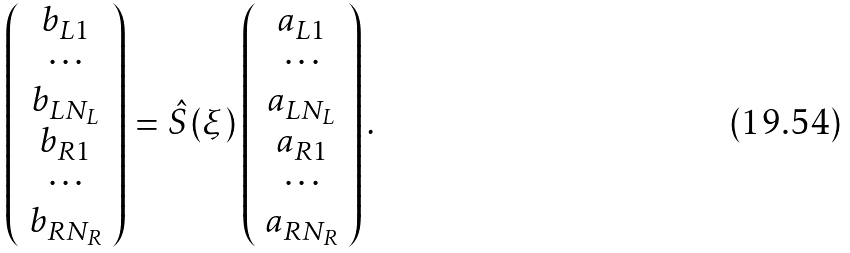Convert formula to latex. <formula><loc_0><loc_0><loc_500><loc_500>\left ( \begin{array} { c } b _ { L 1 } \\ \cdots \\ b _ { L N _ { L } } \\ b _ { R 1 } \\ \cdots \\ b _ { R N _ { R } } \end{array} \right ) = \hat { S } ( \xi ) \left ( \begin{array} { c } a _ { L 1 } \\ \cdots \\ a _ { L N _ { L } } \\ a _ { R 1 } \\ \cdots \\ a _ { R N _ { R } } \end{array} \right ) .</formula> 